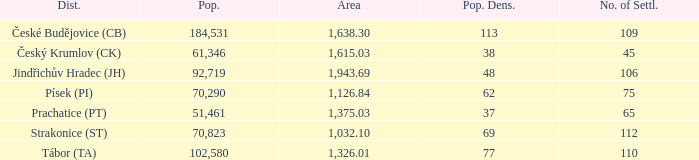How many settlements are in český krumlov (ck) with a population density higher than 38? None. 